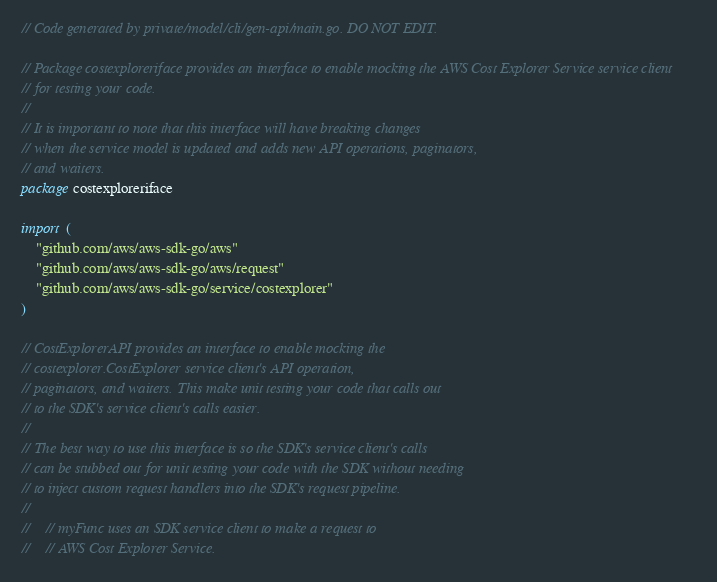<code> <loc_0><loc_0><loc_500><loc_500><_Go_>// Code generated by private/model/cli/gen-api/main.go. DO NOT EDIT.

// Package costexploreriface provides an interface to enable mocking the AWS Cost Explorer Service service client
// for testing your code.
//
// It is important to note that this interface will have breaking changes
// when the service model is updated and adds new API operations, paginators,
// and waiters.
package costexploreriface

import (
	"github.com/aws/aws-sdk-go/aws"
	"github.com/aws/aws-sdk-go/aws/request"
	"github.com/aws/aws-sdk-go/service/costexplorer"
)

// CostExplorerAPI provides an interface to enable mocking the
// costexplorer.CostExplorer service client's API operation,
// paginators, and waiters. This make unit testing your code that calls out
// to the SDK's service client's calls easier.
//
// The best way to use this interface is so the SDK's service client's calls
// can be stubbed out for unit testing your code with the SDK without needing
// to inject custom request handlers into the SDK's request pipeline.
//
//    // myFunc uses an SDK service client to make a request to
//    // AWS Cost Explorer Service.</code> 